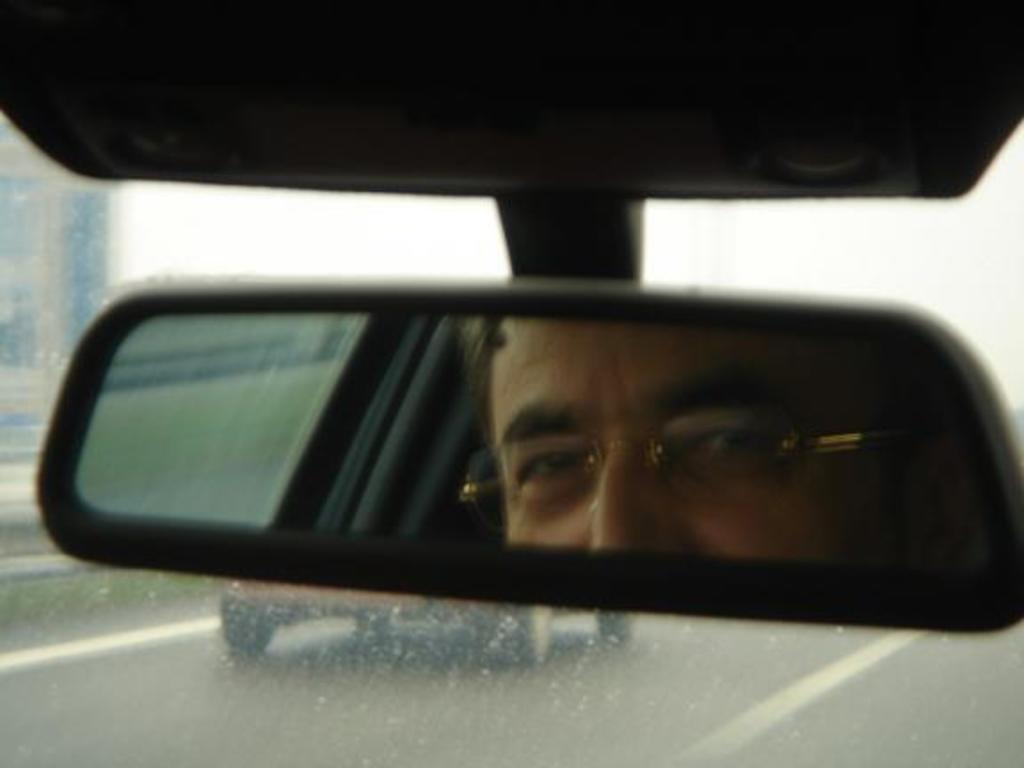What object in the image allows for reflection? There is a mirror in the image that allows for reflection. What can be seen in the mirror's reflection? The reflection of a man is visible in the mirror. What is located behind the mirror? There is a glass and the sky visible behind the mirror. What else can be seen behind the mirror? A road is present behind the mirror. How many flies can be seen on the stove in the image? There is no stove present in the image, so it is not possible to determine the number of flies on it. 